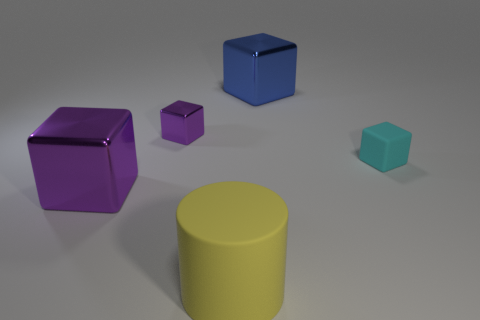Subtract all small cyan blocks. How many blocks are left? 3 Subtract all cyan cubes. How many cubes are left? 3 Subtract all red cylinders. How many purple cubes are left? 2 Add 3 yellow metallic spheres. How many objects exist? 8 Subtract all green cubes. Subtract all green cylinders. How many cubes are left? 4 Subtract all blocks. How many objects are left? 1 Subtract all tiny purple metallic cubes. Subtract all tiny purple shiny cubes. How many objects are left? 3 Add 4 large yellow cylinders. How many large yellow cylinders are left? 5 Add 5 tiny purple metal objects. How many tiny purple metal objects exist? 6 Subtract 0 red spheres. How many objects are left? 5 